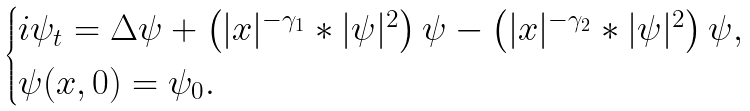<formula> <loc_0><loc_0><loc_500><loc_500>\begin{cases} i \psi _ { t } = \Delta \psi + \left ( | x | ^ { - \gamma _ { 1 } } \ast | \psi | ^ { 2 } \right ) \psi - \left ( | x | ^ { - \gamma _ { 2 } } \ast | \psi | ^ { 2 } \right ) \psi , \\ \psi ( x , 0 ) = \psi _ { 0 } . \end{cases}</formula> 